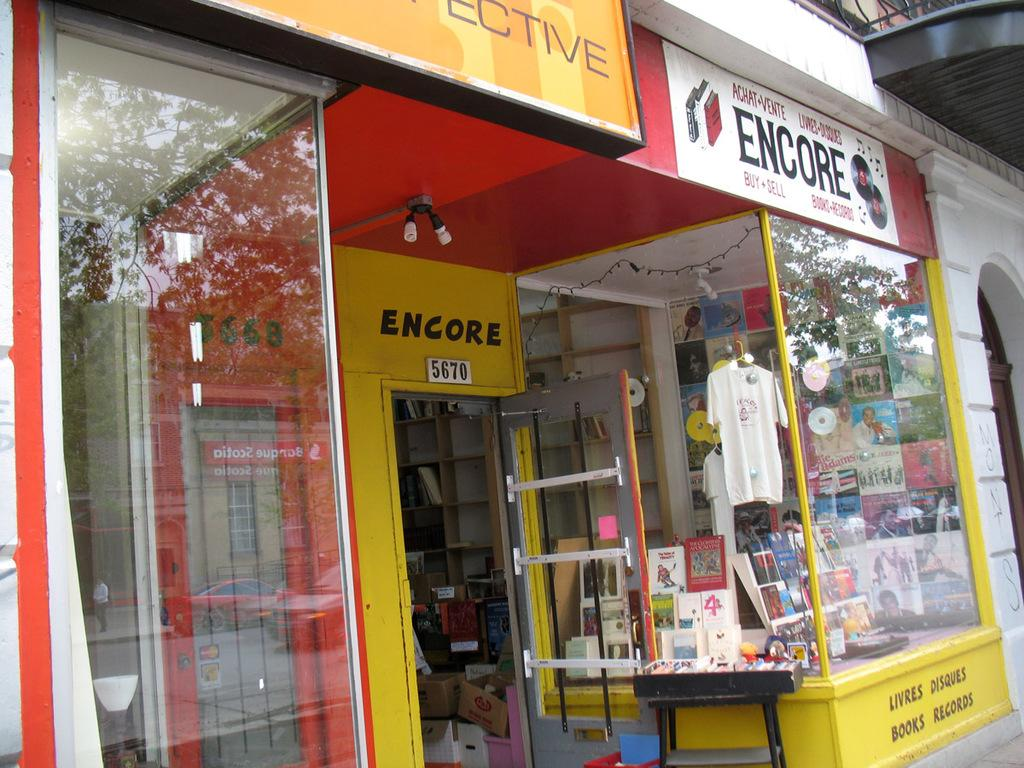<image>
Provide a brief description of the given image. A store shop window from a store called Encore showing shirts and other items. 